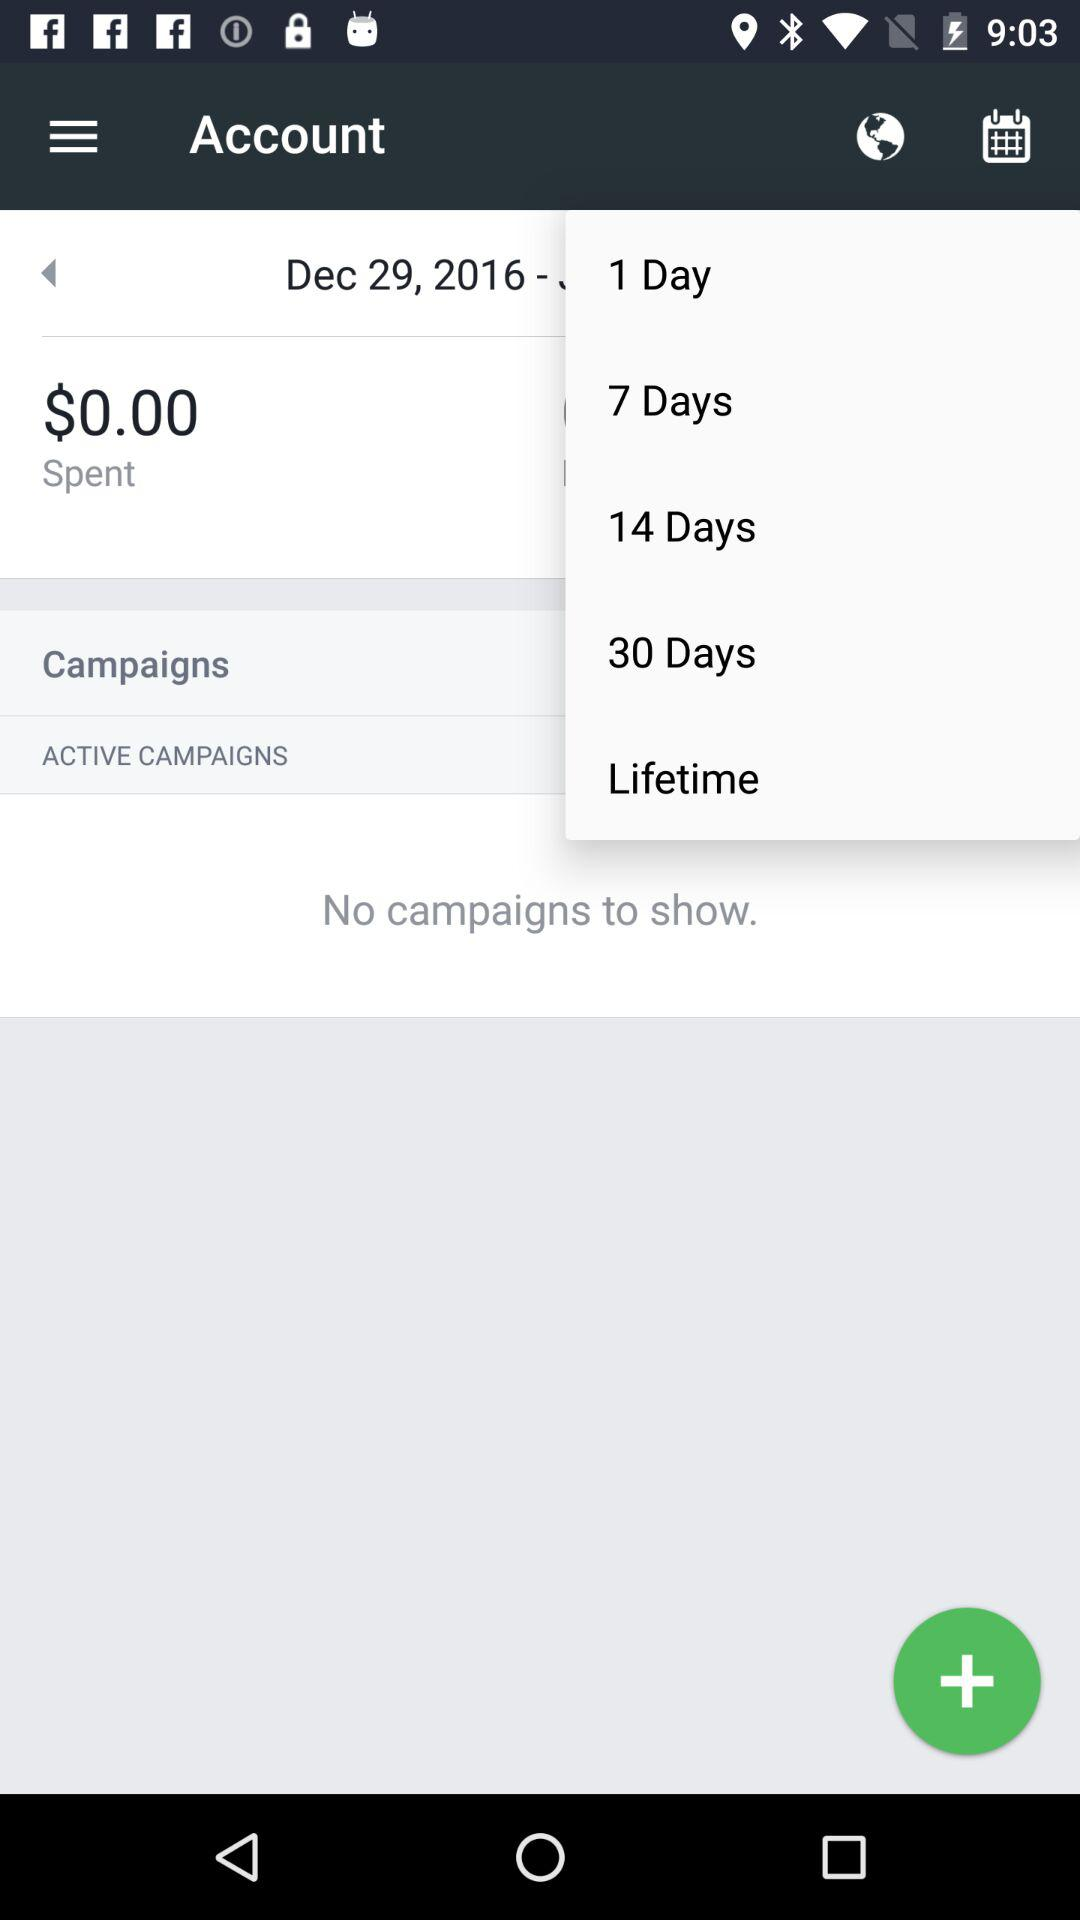How much money has been spent on campaigns?
Answer the question using a single word or phrase. $0.00 